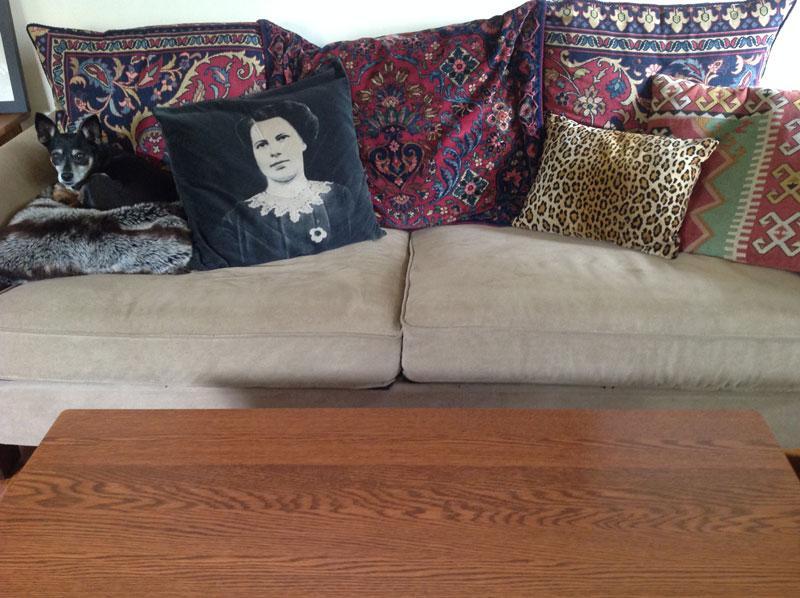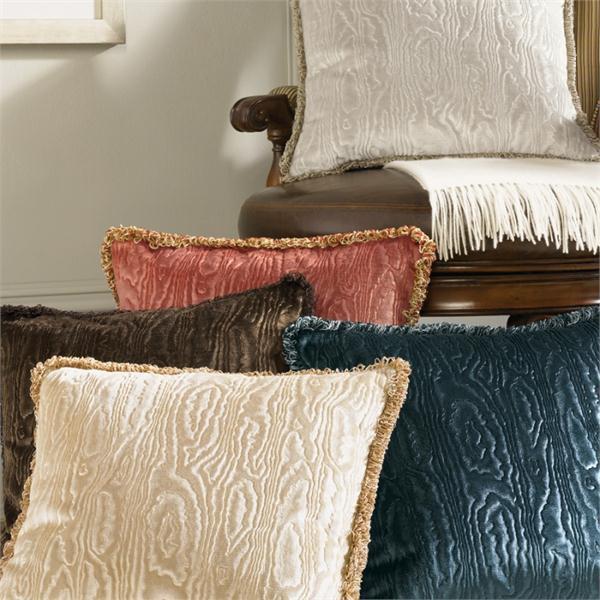The first image is the image on the left, the second image is the image on the right. Assess this claim about the two images: "The right image features multiple fringed pillows with a textured look and colors that include burgundy and brown.". Correct or not? Answer yes or no. Yes. The first image is the image on the left, the second image is the image on the right. Assess this claim about the two images: "Three throw cushions sit on the sofa in the image on the right.". Correct or not? Answer yes or no. No. 